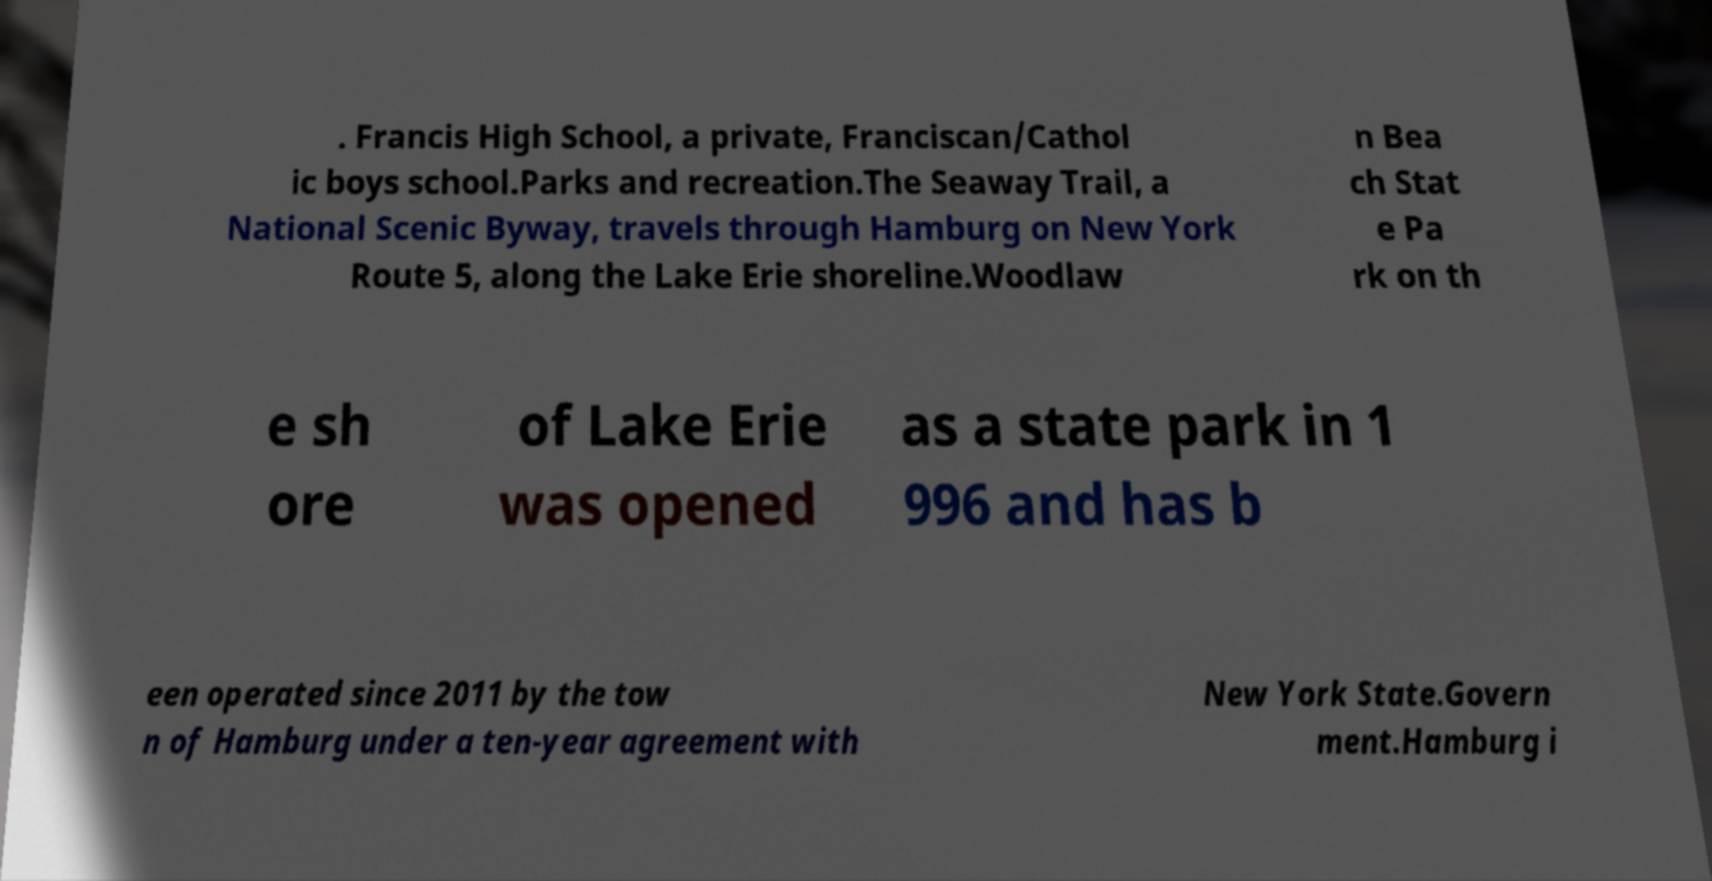Could you extract and type out the text from this image? . Francis High School, a private, Franciscan/Cathol ic boys school.Parks and recreation.The Seaway Trail, a National Scenic Byway, travels through Hamburg on New York Route 5, along the Lake Erie shoreline.Woodlaw n Bea ch Stat e Pa rk on th e sh ore of Lake Erie was opened as a state park in 1 996 and has b een operated since 2011 by the tow n of Hamburg under a ten-year agreement with New York State.Govern ment.Hamburg i 